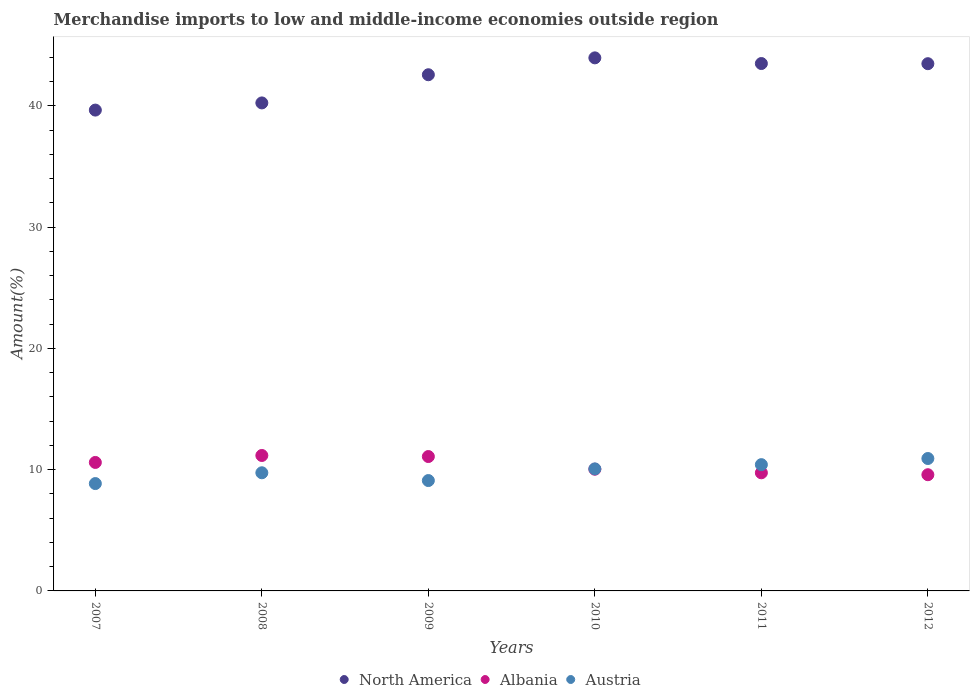What is the percentage of amount earned from merchandise imports in North America in 2007?
Offer a terse response. 39.65. Across all years, what is the maximum percentage of amount earned from merchandise imports in North America?
Make the answer very short. 43.96. Across all years, what is the minimum percentage of amount earned from merchandise imports in Austria?
Your answer should be very brief. 8.85. In which year was the percentage of amount earned from merchandise imports in Albania maximum?
Your answer should be very brief. 2008. In which year was the percentage of amount earned from merchandise imports in North America minimum?
Make the answer very short. 2007. What is the total percentage of amount earned from merchandise imports in Austria in the graph?
Ensure brevity in your answer.  59.09. What is the difference between the percentage of amount earned from merchandise imports in Austria in 2008 and that in 2010?
Make the answer very short. -0.32. What is the difference between the percentage of amount earned from merchandise imports in Albania in 2008 and the percentage of amount earned from merchandise imports in North America in 2007?
Give a very brief answer. -28.48. What is the average percentage of amount earned from merchandise imports in Albania per year?
Your answer should be very brief. 10.37. In the year 2009, what is the difference between the percentage of amount earned from merchandise imports in North America and percentage of amount earned from merchandise imports in Albania?
Your response must be concise. 31.48. In how many years, is the percentage of amount earned from merchandise imports in Albania greater than 34 %?
Provide a short and direct response. 0. What is the ratio of the percentage of amount earned from merchandise imports in Austria in 2008 to that in 2010?
Offer a very short reply. 0.97. Is the difference between the percentage of amount earned from merchandise imports in North America in 2007 and 2009 greater than the difference between the percentage of amount earned from merchandise imports in Albania in 2007 and 2009?
Ensure brevity in your answer.  No. What is the difference between the highest and the second highest percentage of amount earned from merchandise imports in Albania?
Your response must be concise. 0.09. What is the difference between the highest and the lowest percentage of amount earned from merchandise imports in Albania?
Offer a terse response. 1.59. In how many years, is the percentage of amount earned from merchandise imports in Albania greater than the average percentage of amount earned from merchandise imports in Albania taken over all years?
Your response must be concise. 3. Is the sum of the percentage of amount earned from merchandise imports in North America in 2008 and 2012 greater than the maximum percentage of amount earned from merchandise imports in Austria across all years?
Give a very brief answer. Yes. Is the percentage of amount earned from merchandise imports in Austria strictly greater than the percentage of amount earned from merchandise imports in Albania over the years?
Give a very brief answer. No. Is the percentage of amount earned from merchandise imports in North America strictly less than the percentage of amount earned from merchandise imports in Albania over the years?
Ensure brevity in your answer.  No. How many years are there in the graph?
Provide a short and direct response. 6. Does the graph contain any zero values?
Provide a succinct answer. No. Does the graph contain grids?
Offer a terse response. No. How many legend labels are there?
Offer a very short reply. 3. How are the legend labels stacked?
Offer a very short reply. Horizontal. What is the title of the graph?
Ensure brevity in your answer.  Merchandise imports to low and middle-income economies outside region. Does "Belarus" appear as one of the legend labels in the graph?
Provide a succinct answer. No. What is the label or title of the Y-axis?
Make the answer very short. Amount(%). What is the Amount(%) of North America in 2007?
Offer a very short reply. 39.65. What is the Amount(%) in Albania in 2007?
Make the answer very short. 10.59. What is the Amount(%) in Austria in 2007?
Your answer should be compact. 8.85. What is the Amount(%) of North America in 2008?
Offer a terse response. 40.24. What is the Amount(%) in Albania in 2008?
Provide a short and direct response. 11.17. What is the Amount(%) in Austria in 2008?
Provide a short and direct response. 9.74. What is the Amount(%) of North America in 2009?
Provide a succinct answer. 42.57. What is the Amount(%) in Albania in 2009?
Your response must be concise. 11.08. What is the Amount(%) in Austria in 2009?
Give a very brief answer. 9.1. What is the Amount(%) in North America in 2010?
Ensure brevity in your answer.  43.96. What is the Amount(%) in Albania in 2010?
Offer a very short reply. 10.04. What is the Amount(%) of Austria in 2010?
Your response must be concise. 10.06. What is the Amount(%) of North America in 2011?
Your answer should be compact. 43.49. What is the Amount(%) of Albania in 2011?
Ensure brevity in your answer.  9.74. What is the Amount(%) of Austria in 2011?
Offer a terse response. 10.41. What is the Amount(%) in North America in 2012?
Offer a terse response. 43.48. What is the Amount(%) in Albania in 2012?
Provide a succinct answer. 9.58. What is the Amount(%) of Austria in 2012?
Your response must be concise. 10.92. Across all years, what is the maximum Amount(%) in North America?
Offer a terse response. 43.96. Across all years, what is the maximum Amount(%) in Albania?
Give a very brief answer. 11.17. Across all years, what is the maximum Amount(%) of Austria?
Provide a short and direct response. 10.92. Across all years, what is the minimum Amount(%) of North America?
Offer a terse response. 39.65. Across all years, what is the minimum Amount(%) of Albania?
Your answer should be very brief. 9.58. Across all years, what is the minimum Amount(%) in Austria?
Provide a succinct answer. 8.85. What is the total Amount(%) of North America in the graph?
Give a very brief answer. 253.38. What is the total Amount(%) in Albania in the graph?
Keep it short and to the point. 62.2. What is the total Amount(%) in Austria in the graph?
Keep it short and to the point. 59.09. What is the difference between the Amount(%) in North America in 2007 and that in 2008?
Your answer should be compact. -0.59. What is the difference between the Amount(%) of Albania in 2007 and that in 2008?
Your answer should be compact. -0.57. What is the difference between the Amount(%) of Austria in 2007 and that in 2008?
Offer a terse response. -0.89. What is the difference between the Amount(%) of North America in 2007 and that in 2009?
Give a very brief answer. -2.91. What is the difference between the Amount(%) in Albania in 2007 and that in 2009?
Ensure brevity in your answer.  -0.49. What is the difference between the Amount(%) of Austria in 2007 and that in 2009?
Provide a short and direct response. -0.25. What is the difference between the Amount(%) in North America in 2007 and that in 2010?
Keep it short and to the point. -4.31. What is the difference between the Amount(%) in Albania in 2007 and that in 2010?
Your answer should be very brief. 0.56. What is the difference between the Amount(%) of Austria in 2007 and that in 2010?
Provide a short and direct response. -1.21. What is the difference between the Amount(%) of North America in 2007 and that in 2011?
Your answer should be compact. -3.84. What is the difference between the Amount(%) of Albania in 2007 and that in 2011?
Provide a short and direct response. 0.85. What is the difference between the Amount(%) in Austria in 2007 and that in 2011?
Offer a terse response. -1.56. What is the difference between the Amount(%) in North America in 2007 and that in 2012?
Offer a very short reply. -3.83. What is the difference between the Amount(%) in Albania in 2007 and that in 2012?
Ensure brevity in your answer.  1.01. What is the difference between the Amount(%) of Austria in 2007 and that in 2012?
Your answer should be compact. -2.07. What is the difference between the Amount(%) in North America in 2008 and that in 2009?
Provide a succinct answer. -2.32. What is the difference between the Amount(%) of Albania in 2008 and that in 2009?
Your response must be concise. 0.09. What is the difference between the Amount(%) in Austria in 2008 and that in 2009?
Give a very brief answer. 0.64. What is the difference between the Amount(%) of North America in 2008 and that in 2010?
Provide a succinct answer. -3.72. What is the difference between the Amount(%) of Albania in 2008 and that in 2010?
Make the answer very short. 1.13. What is the difference between the Amount(%) in Austria in 2008 and that in 2010?
Offer a terse response. -0.32. What is the difference between the Amount(%) in North America in 2008 and that in 2011?
Ensure brevity in your answer.  -3.25. What is the difference between the Amount(%) of Albania in 2008 and that in 2011?
Offer a terse response. 1.43. What is the difference between the Amount(%) in Austria in 2008 and that in 2011?
Ensure brevity in your answer.  -0.67. What is the difference between the Amount(%) in North America in 2008 and that in 2012?
Provide a succinct answer. -3.23. What is the difference between the Amount(%) in Albania in 2008 and that in 2012?
Your answer should be compact. 1.59. What is the difference between the Amount(%) in Austria in 2008 and that in 2012?
Give a very brief answer. -1.18. What is the difference between the Amount(%) in North America in 2009 and that in 2010?
Your response must be concise. -1.39. What is the difference between the Amount(%) of Albania in 2009 and that in 2010?
Ensure brevity in your answer.  1.04. What is the difference between the Amount(%) of Austria in 2009 and that in 2010?
Your answer should be compact. -0.96. What is the difference between the Amount(%) in North America in 2009 and that in 2011?
Provide a succinct answer. -0.92. What is the difference between the Amount(%) in Albania in 2009 and that in 2011?
Your answer should be very brief. 1.34. What is the difference between the Amount(%) in Austria in 2009 and that in 2011?
Your answer should be compact. -1.31. What is the difference between the Amount(%) of North America in 2009 and that in 2012?
Give a very brief answer. -0.91. What is the difference between the Amount(%) in Albania in 2009 and that in 2012?
Keep it short and to the point. 1.5. What is the difference between the Amount(%) in Austria in 2009 and that in 2012?
Provide a succinct answer. -1.82. What is the difference between the Amount(%) in North America in 2010 and that in 2011?
Make the answer very short. 0.47. What is the difference between the Amount(%) in Albania in 2010 and that in 2011?
Provide a short and direct response. 0.3. What is the difference between the Amount(%) in Austria in 2010 and that in 2011?
Offer a terse response. -0.35. What is the difference between the Amount(%) of North America in 2010 and that in 2012?
Offer a very short reply. 0.48. What is the difference between the Amount(%) in Albania in 2010 and that in 2012?
Offer a terse response. 0.45. What is the difference between the Amount(%) of Austria in 2010 and that in 2012?
Your response must be concise. -0.86. What is the difference between the Amount(%) in North America in 2011 and that in 2012?
Make the answer very short. 0.01. What is the difference between the Amount(%) in Albania in 2011 and that in 2012?
Provide a succinct answer. 0.16. What is the difference between the Amount(%) in Austria in 2011 and that in 2012?
Keep it short and to the point. -0.51. What is the difference between the Amount(%) in North America in 2007 and the Amount(%) in Albania in 2008?
Offer a terse response. 28.48. What is the difference between the Amount(%) in North America in 2007 and the Amount(%) in Austria in 2008?
Give a very brief answer. 29.91. What is the difference between the Amount(%) in Albania in 2007 and the Amount(%) in Austria in 2008?
Give a very brief answer. 0.85. What is the difference between the Amount(%) of North America in 2007 and the Amount(%) of Albania in 2009?
Give a very brief answer. 28.57. What is the difference between the Amount(%) in North America in 2007 and the Amount(%) in Austria in 2009?
Offer a terse response. 30.55. What is the difference between the Amount(%) in Albania in 2007 and the Amount(%) in Austria in 2009?
Provide a short and direct response. 1.49. What is the difference between the Amount(%) of North America in 2007 and the Amount(%) of Albania in 2010?
Provide a short and direct response. 29.61. What is the difference between the Amount(%) of North America in 2007 and the Amount(%) of Austria in 2010?
Your answer should be very brief. 29.59. What is the difference between the Amount(%) of Albania in 2007 and the Amount(%) of Austria in 2010?
Give a very brief answer. 0.53. What is the difference between the Amount(%) of North America in 2007 and the Amount(%) of Albania in 2011?
Your response must be concise. 29.91. What is the difference between the Amount(%) in North America in 2007 and the Amount(%) in Austria in 2011?
Make the answer very short. 29.24. What is the difference between the Amount(%) of Albania in 2007 and the Amount(%) of Austria in 2011?
Offer a very short reply. 0.18. What is the difference between the Amount(%) in North America in 2007 and the Amount(%) in Albania in 2012?
Give a very brief answer. 30.07. What is the difference between the Amount(%) of North America in 2007 and the Amount(%) of Austria in 2012?
Keep it short and to the point. 28.73. What is the difference between the Amount(%) of Albania in 2007 and the Amount(%) of Austria in 2012?
Ensure brevity in your answer.  -0.32. What is the difference between the Amount(%) of North America in 2008 and the Amount(%) of Albania in 2009?
Keep it short and to the point. 29.16. What is the difference between the Amount(%) in North America in 2008 and the Amount(%) in Austria in 2009?
Your answer should be very brief. 31.14. What is the difference between the Amount(%) of Albania in 2008 and the Amount(%) of Austria in 2009?
Your response must be concise. 2.07. What is the difference between the Amount(%) in North America in 2008 and the Amount(%) in Albania in 2010?
Provide a short and direct response. 30.21. What is the difference between the Amount(%) of North America in 2008 and the Amount(%) of Austria in 2010?
Give a very brief answer. 30.18. What is the difference between the Amount(%) in Albania in 2008 and the Amount(%) in Austria in 2010?
Keep it short and to the point. 1.11. What is the difference between the Amount(%) of North America in 2008 and the Amount(%) of Albania in 2011?
Your response must be concise. 30.5. What is the difference between the Amount(%) in North America in 2008 and the Amount(%) in Austria in 2011?
Your response must be concise. 29.83. What is the difference between the Amount(%) in Albania in 2008 and the Amount(%) in Austria in 2011?
Your answer should be compact. 0.76. What is the difference between the Amount(%) of North America in 2008 and the Amount(%) of Albania in 2012?
Offer a terse response. 30.66. What is the difference between the Amount(%) in North America in 2008 and the Amount(%) in Austria in 2012?
Ensure brevity in your answer.  29.32. What is the difference between the Amount(%) in North America in 2009 and the Amount(%) in Albania in 2010?
Provide a succinct answer. 32.53. What is the difference between the Amount(%) of North America in 2009 and the Amount(%) of Austria in 2010?
Your response must be concise. 32.5. What is the difference between the Amount(%) of Albania in 2009 and the Amount(%) of Austria in 2010?
Your answer should be very brief. 1.02. What is the difference between the Amount(%) in North America in 2009 and the Amount(%) in Albania in 2011?
Your response must be concise. 32.83. What is the difference between the Amount(%) in North America in 2009 and the Amount(%) in Austria in 2011?
Your answer should be very brief. 32.15. What is the difference between the Amount(%) of Albania in 2009 and the Amount(%) of Austria in 2011?
Ensure brevity in your answer.  0.67. What is the difference between the Amount(%) in North America in 2009 and the Amount(%) in Albania in 2012?
Make the answer very short. 32.98. What is the difference between the Amount(%) in North America in 2009 and the Amount(%) in Austria in 2012?
Your response must be concise. 31.65. What is the difference between the Amount(%) in Albania in 2009 and the Amount(%) in Austria in 2012?
Offer a terse response. 0.16. What is the difference between the Amount(%) of North America in 2010 and the Amount(%) of Albania in 2011?
Give a very brief answer. 34.22. What is the difference between the Amount(%) in North America in 2010 and the Amount(%) in Austria in 2011?
Ensure brevity in your answer.  33.54. What is the difference between the Amount(%) in Albania in 2010 and the Amount(%) in Austria in 2011?
Give a very brief answer. -0.38. What is the difference between the Amount(%) in North America in 2010 and the Amount(%) in Albania in 2012?
Your response must be concise. 34.38. What is the difference between the Amount(%) in North America in 2010 and the Amount(%) in Austria in 2012?
Provide a succinct answer. 33.04. What is the difference between the Amount(%) in Albania in 2010 and the Amount(%) in Austria in 2012?
Give a very brief answer. -0.88. What is the difference between the Amount(%) of North America in 2011 and the Amount(%) of Albania in 2012?
Keep it short and to the point. 33.91. What is the difference between the Amount(%) in North America in 2011 and the Amount(%) in Austria in 2012?
Offer a very short reply. 32.57. What is the difference between the Amount(%) in Albania in 2011 and the Amount(%) in Austria in 2012?
Make the answer very short. -1.18. What is the average Amount(%) in North America per year?
Offer a terse response. 42.23. What is the average Amount(%) of Albania per year?
Provide a short and direct response. 10.37. What is the average Amount(%) of Austria per year?
Offer a terse response. 9.85. In the year 2007, what is the difference between the Amount(%) in North America and Amount(%) in Albania?
Make the answer very short. 29.06. In the year 2007, what is the difference between the Amount(%) of North America and Amount(%) of Austria?
Keep it short and to the point. 30.8. In the year 2007, what is the difference between the Amount(%) of Albania and Amount(%) of Austria?
Give a very brief answer. 1.74. In the year 2008, what is the difference between the Amount(%) of North America and Amount(%) of Albania?
Offer a terse response. 29.07. In the year 2008, what is the difference between the Amount(%) in North America and Amount(%) in Austria?
Your answer should be very brief. 30.5. In the year 2008, what is the difference between the Amount(%) in Albania and Amount(%) in Austria?
Your answer should be very brief. 1.43. In the year 2009, what is the difference between the Amount(%) of North America and Amount(%) of Albania?
Offer a terse response. 31.48. In the year 2009, what is the difference between the Amount(%) in North America and Amount(%) in Austria?
Your answer should be very brief. 33.46. In the year 2009, what is the difference between the Amount(%) in Albania and Amount(%) in Austria?
Ensure brevity in your answer.  1.98. In the year 2010, what is the difference between the Amount(%) in North America and Amount(%) in Albania?
Offer a terse response. 33.92. In the year 2010, what is the difference between the Amount(%) in North America and Amount(%) in Austria?
Make the answer very short. 33.89. In the year 2010, what is the difference between the Amount(%) of Albania and Amount(%) of Austria?
Provide a short and direct response. -0.03. In the year 2011, what is the difference between the Amount(%) of North America and Amount(%) of Albania?
Give a very brief answer. 33.75. In the year 2011, what is the difference between the Amount(%) in North America and Amount(%) in Austria?
Provide a short and direct response. 33.08. In the year 2011, what is the difference between the Amount(%) of Albania and Amount(%) of Austria?
Your answer should be very brief. -0.67. In the year 2012, what is the difference between the Amount(%) in North America and Amount(%) in Albania?
Ensure brevity in your answer.  33.89. In the year 2012, what is the difference between the Amount(%) in North America and Amount(%) in Austria?
Make the answer very short. 32.56. In the year 2012, what is the difference between the Amount(%) of Albania and Amount(%) of Austria?
Keep it short and to the point. -1.34. What is the ratio of the Amount(%) in Albania in 2007 to that in 2008?
Keep it short and to the point. 0.95. What is the ratio of the Amount(%) in Austria in 2007 to that in 2008?
Ensure brevity in your answer.  0.91. What is the ratio of the Amount(%) in North America in 2007 to that in 2009?
Your response must be concise. 0.93. What is the ratio of the Amount(%) in Albania in 2007 to that in 2009?
Ensure brevity in your answer.  0.96. What is the ratio of the Amount(%) in Austria in 2007 to that in 2009?
Give a very brief answer. 0.97. What is the ratio of the Amount(%) in North America in 2007 to that in 2010?
Ensure brevity in your answer.  0.9. What is the ratio of the Amount(%) in Albania in 2007 to that in 2010?
Keep it short and to the point. 1.06. What is the ratio of the Amount(%) in Austria in 2007 to that in 2010?
Your answer should be very brief. 0.88. What is the ratio of the Amount(%) in North America in 2007 to that in 2011?
Your response must be concise. 0.91. What is the ratio of the Amount(%) of Albania in 2007 to that in 2011?
Offer a very short reply. 1.09. What is the ratio of the Amount(%) of Austria in 2007 to that in 2011?
Your answer should be very brief. 0.85. What is the ratio of the Amount(%) of North America in 2007 to that in 2012?
Your response must be concise. 0.91. What is the ratio of the Amount(%) of Albania in 2007 to that in 2012?
Provide a succinct answer. 1.11. What is the ratio of the Amount(%) of Austria in 2007 to that in 2012?
Give a very brief answer. 0.81. What is the ratio of the Amount(%) in North America in 2008 to that in 2009?
Your response must be concise. 0.95. What is the ratio of the Amount(%) of Albania in 2008 to that in 2009?
Offer a terse response. 1.01. What is the ratio of the Amount(%) of Austria in 2008 to that in 2009?
Provide a short and direct response. 1.07. What is the ratio of the Amount(%) of North America in 2008 to that in 2010?
Offer a very short reply. 0.92. What is the ratio of the Amount(%) of Albania in 2008 to that in 2010?
Provide a succinct answer. 1.11. What is the ratio of the Amount(%) in Austria in 2008 to that in 2010?
Offer a terse response. 0.97. What is the ratio of the Amount(%) of North America in 2008 to that in 2011?
Provide a succinct answer. 0.93. What is the ratio of the Amount(%) in Albania in 2008 to that in 2011?
Keep it short and to the point. 1.15. What is the ratio of the Amount(%) of Austria in 2008 to that in 2011?
Offer a terse response. 0.94. What is the ratio of the Amount(%) in North America in 2008 to that in 2012?
Your answer should be compact. 0.93. What is the ratio of the Amount(%) of Albania in 2008 to that in 2012?
Your response must be concise. 1.17. What is the ratio of the Amount(%) of Austria in 2008 to that in 2012?
Your answer should be compact. 0.89. What is the ratio of the Amount(%) of North America in 2009 to that in 2010?
Provide a succinct answer. 0.97. What is the ratio of the Amount(%) of Albania in 2009 to that in 2010?
Keep it short and to the point. 1.1. What is the ratio of the Amount(%) of Austria in 2009 to that in 2010?
Your response must be concise. 0.9. What is the ratio of the Amount(%) in North America in 2009 to that in 2011?
Give a very brief answer. 0.98. What is the ratio of the Amount(%) in Albania in 2009 to that in 2011?
Your answer should be compact. 1.14. What is the ratio of the Amount(%) of Austria in 2009 to that in 2011?
Your answer should be very brief. 0.87. What is the ratio of the Amount(%) of Albania in 2009 to that in 2012?
Provide a succinct answer. 1.16. What is the ratio of the Amount(%) in Austria in 2009 to that in 2012?
Provide a short and direct response. 0.83. What is the ratio of the Amount(%) of North America in 2010 to that in 2011?
Ensure brevity in your answer.  1.01. What is the ratio of the Amount(%) in Albania in 2010 to that in 2011?
Offer a terse response. 1.03. What is the ratio of the Amount(%) of Austria in 2010 to that in 2011?
Keep it short and to the point. 0.97. What is the ratio of the Amount(%) in North America in 2010 to that in 2012?
Keep it short and to the point. 1.01. What is the ratio of the Amount(%) of Albania in 2010 to that in 2012?
Offer a terse response. 1.05. What is the ratio of the Amount(%) in Austria in 2010 to that in 2012?
Make the answer very short. 0.92. What is the ratio of the Amount(%) in Albania in 2011 to that in 2012?
Offer a terse response. 1.02. What is the ratio of the Amount(%) in Austria in 2011 to that in 2012?
Offer a terse response. 0.95. What is the difference between the highest and the second highest Amount(%) of North America?
Provide a succinct answer. 0.47. What is the difference between the highest and the second highest Amount(%) of Albania?
Give a very brief answer. 0.09. What is the difference between the highest and the second highest Amount(%) in Austria?
Give a very brief answer. 0.51. What is the difference between the highest and the lowest Amount(%) in North America?
Offer a very short reply. 4.31. What is the difference between the highest and the lowest Amount(%) in Albania?
Keep it short and to the point. 1.59. What is the difference between the highest and the lowest Amount(%) of Austria?
Ensure brevity in your answer.  2.07. 